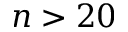<formula> <loc_0><loc_0><loc_500><loc_500>n > 2 0</formula> 